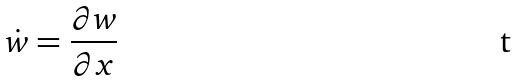<formula> <loc_0><loc_0><loc_500><loc_500>\dot { w } = \frac { \partial w } { \partial x }</formula> 